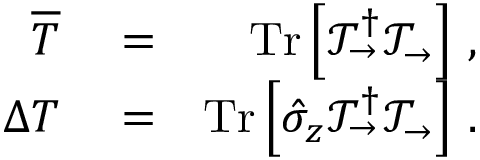Convert formula to latex. <formula><loc_0><loc_0><loc_500><loc_500>\begin{array} { r l r } { \overline { T } } & = } & { T r \left [ \mathcal { T } _ { \rightarrow } ^ { \dagger } \mathcal { T } _ { \rightarrow } \right ] \, , } \\ { \Delta { T } } & = } & { T r \left [ \hat { \sigma } _ { z } \mathcal { T } _ { \rightarrow } ^ { \dagger } \mathcal { T } _ { \rightarrow } \right ] \, . } \end{array}</formula> 